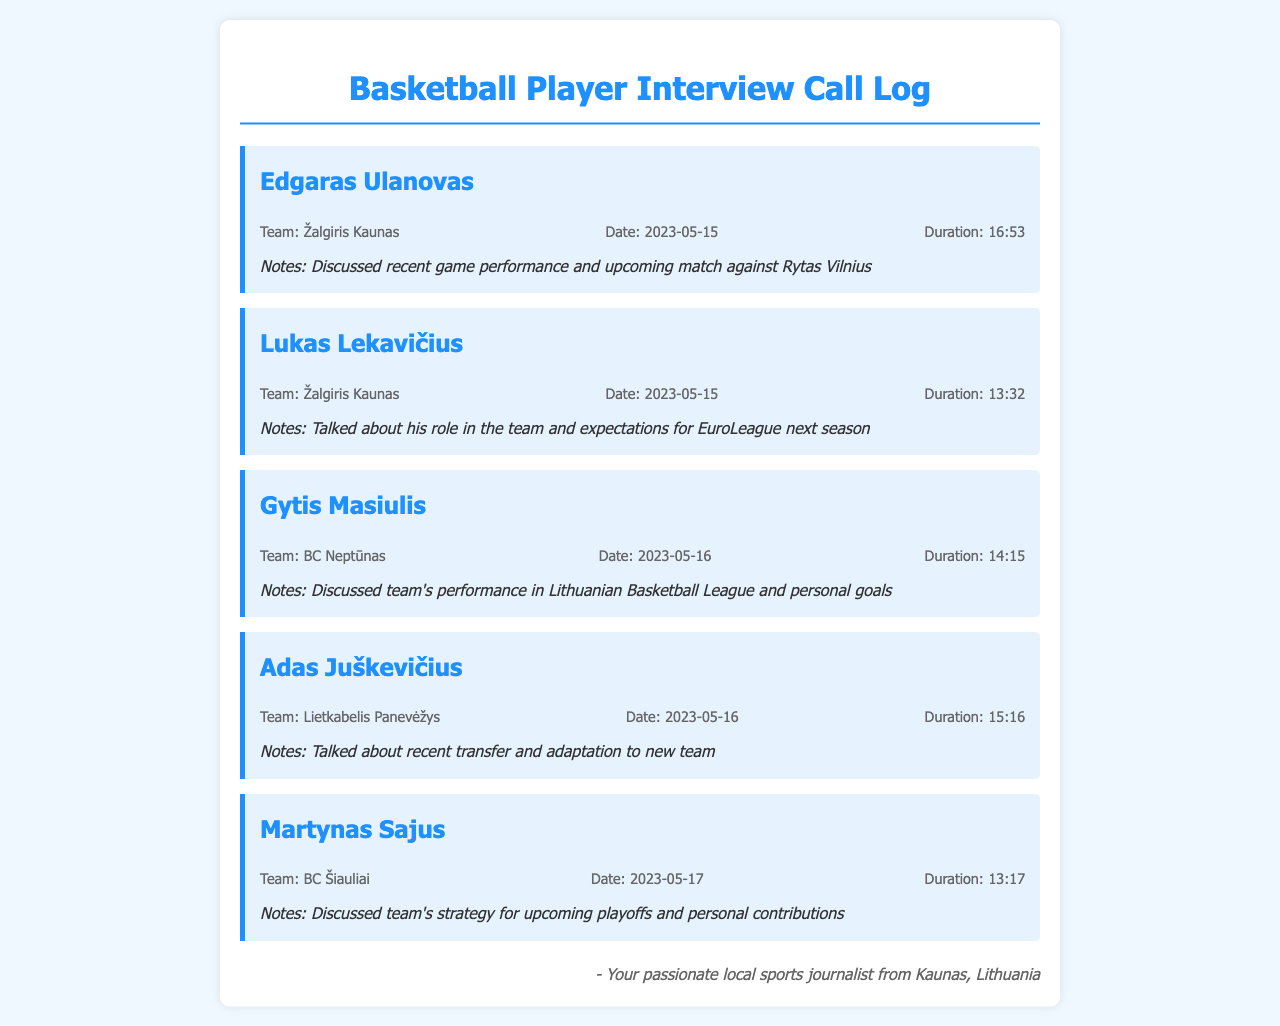What is the name of the first player interviewed? The first player listed in the call log is Edgaras Ulanovas.
Answer: Edgaras Ulanovas What team does Lukas Lekavičius play for? The document indicates that Lukas Lekavičius is part of Žalgiris Kaunas.
Answer: Žalgiris Kaunas On what date did Adas Juškevičius's interview take place? The interview with Adas Juškevičius was conducted on 2023-05-16.
Answer: 2023-05-16 What was the duration of Gytis Masiulis's interview? The call log states that Gytis Masiulis's interview lasted for 14:15.
Answer: 14:15 Which player discussed their role in the team during their interview? The notes for Lukas Lekavičius indicate he talked about his role in the team.
Answer: Lukas Lekavičius How many interviews took place on May 16, 2023? Two interviews were conducted on that date: Gytis Masiulis and Adas Juškevičius.
Answer: 2 What is the total duration of the interviews listed in the document? The total duration is calculated by adding all individual durations: 16:53 + 13:32 + 14:15 + 15:16 + 13:17. The total is approximately 73 minutes and 13 seconds.
Answer: Approximately 73:13 Which player mentioned adaptation to a new team? Adas Juškevičius mentioned adaptation to his new team in the notes.
Answer: Adas Juškevičius What is the last player's name listed in the document? The last player mentioned in the call log is Martynas Sajus.
Answer: Martynas Sajus 